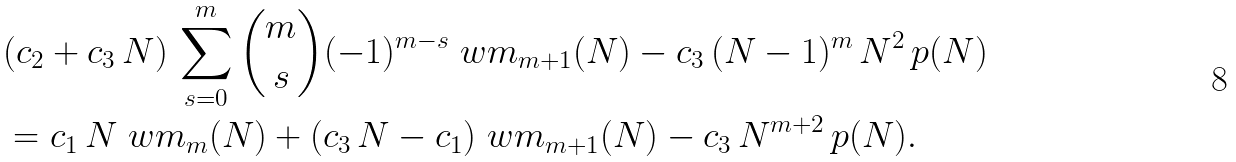Convert formula to latex. <formula><loc_0><loc_0><loc_500><loc_500>& ( c _ { 2 } + c _ { 3 } \, N ) \, \sum _ { s = 0 } ^ { m } \binom { m } { s } ( - 1 ) ^ { m - s } \ w m _ { m + 1 } ( N ) - c _ { 3 } \, ( N - 1 ) ^ { m } \, N ^ { 2 } \, p ( N ) \\ & = c _ { 1 } \, N \ w m _ { m } ( N ) + ( c _ { 3 } \, N - c _ { 1 } ) \ w m _ { m + 1 } ( N ) - c _ { 3 } \, N ^ { m + 2 } \, p ( N ) .</formula> 